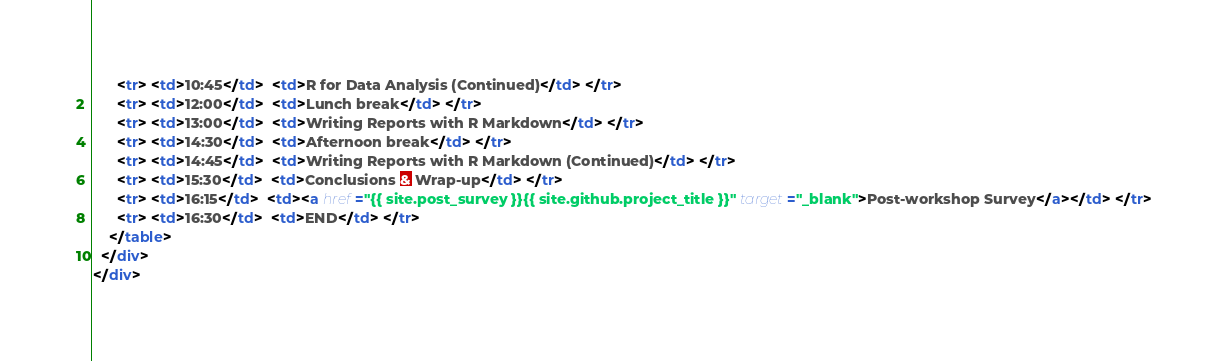<code> <loc_0><loc_0><loc_500><loc_500><_HTML_>      <tr> <td>10:45</td>  <td>R for Data Analysis (Continued)</td> </tr>
      <tr> <td>12:00</td>  <td>Lunch break</td> </tr>
      <tr> <td>13:00</td>  <td>Writing Reports with R Markdown</td> </tr>
      <tr> <td>14:30</td>  <td>Afternoon break</td> </tr>
      <tr> <td>14:45</td>  <td>Writing Reports with R Markdown (Continued)</td> </tr>
      <tr> <td>15:30</td>  <td>Conclusions & Wrap-up</td> </tr>
      <tr> <td>16:15</td>  <td><a href="{{ site.post_survey }}{{ site.github.project_title }}" target="_blank">Post-workshop Survey</a></td> </tr>
      <tr> <td>16:30</td>  <td>END</td> </tr>
    </table>
  </div>
</div></code> 